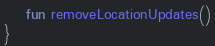Convert code to text. <code><loc_0><loc_0><loc_500><loc_500><_Kotlin_>    fun removeLocationUpdates()
}</code> 